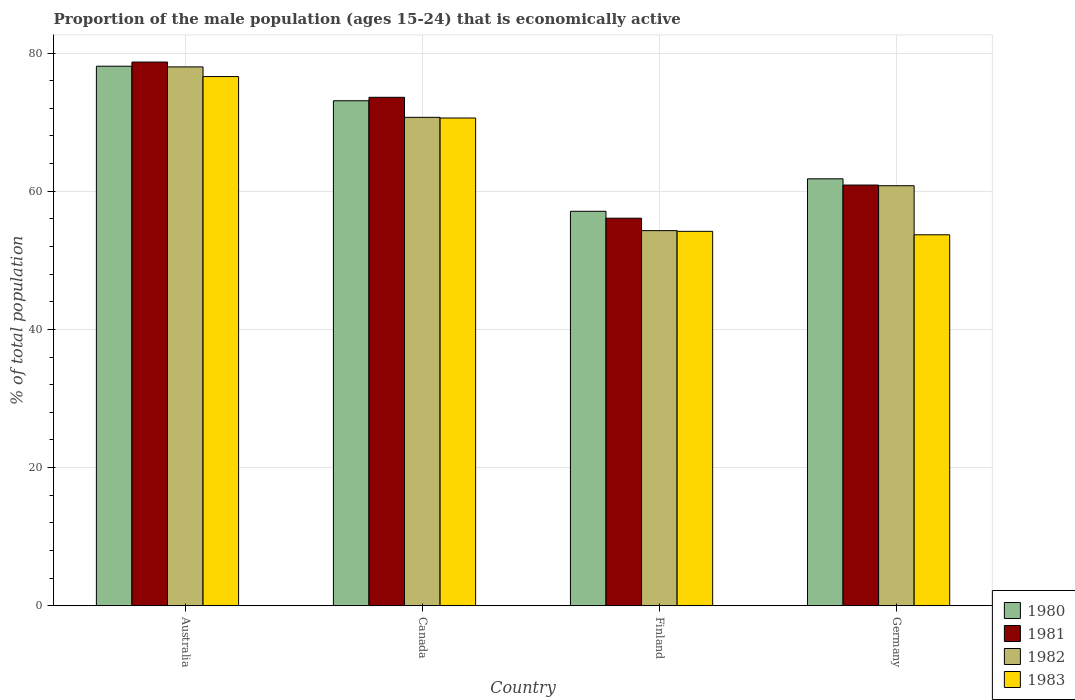How many different coloured bars are there?
Provide a short and direct response. 4. Are the number of bars per tick equal to the number of legend labels?
Provide a short and direct response. Yes. How many bars are there on the 3rd tick from the left?
Make the answer very short. 4. In how many cases, is the number of bars for a given country not equal to the number of legend labels?
Your answer should be very brief. 0. What is the proportion of the male population that is economically active in 1980 in Canada?
Offer a terse response. 73.1. Across all countries, what is the maximum proportion of the male population that is economically active in 1980?
Keep it short and to the point. 78.1. Across all countries, what is the minimum proportion of the male population that is economically active in 1982?
Ensure brevity in your answer.  54.3. In which country was the proportion of the male population that is economically active in 1980 maximum?
Give a very brief answer. Australia. What is the total proportion of the male population that is economically active in 1980 in the graph?
Your response must be concise. 270.1. What is the difference between the proportion of the male population that is economically active in 1982 in Canada and that in Germany?
Offer a terse response. 9.9. What is the difference between the proportion of the male population that is economically active in 1982 in Finland and the proportion of the male population that is economically active in 1981 in Germany?
Offer a very short reply. -6.6. What is the average proportion of the male population that is economically active in 1982 per country?
Keep it short and to the point. 65.95. What is the difference between the proportion of the male population that is economically active of/in 1980 and proportion of the male population that is economically active of/in 1982 in Australia?
Your answer should be compact. 0.1. What is the ratio of the proportion of the male population that is economically active in 1982 in Canada to that in Finland?
Keep it short and to the point. 1.3. Is the proportion of the male population that is economically active in 1982 in Australia less than that in Canada?
Ensure brevity in your answer.  No. What is the difference between the highest and the second highest proportion of the male population that is economically active in 1980?
Offer a very short reply. 11.3. What is the difference between the highest and the lowest proportion of the male population that is economically active in 1980?
Your answer should be compact. 21. In how many countries, is the proportion of the male population that is economically active in 1981 greater than the average proportion of the male population that is economically active in 1981 taken over all countries?
Provide a succinct answer. 2. Is it the case that in every country, the sum of the proportion of the male population that is economically active in 1982 and proportion of the male population that is economically active in 1983 is greater than the sum of proportion of the male population that is economically active in 1980 and proportion of the male population that is economically active in 1981?
Ensure brevity in your answer.  No. How many countries are there in the graph?
Your response must be concise. 4. What is the difference between two consecutive major ticks on the Y-axis?
Your response must be concise. 20. Where does the legend appear in the graph?
Your answer should be compact. Bottom right. How many legend labels are there?
Provide a succinct answer. 4. How are the legend labels stacked?
Offer a terse response. Vertical. What is the title of the graph?
Your response must be concise. Proportion of the male population (ages 15-24) that is economically active. What is the label or title of the X-axis?
Keep it short and to the point. Country. What is the label or title of the Y-axis?
Your answer should be compact. % of total population. What is the % of total population in 1980 in Australia?
Your response must be concise. 78.1. What is the % of total population of 1981 in Australia?
Give a very brief answer. 78.7. What is the % of total population in 1982 in Australia?
Ensure brevity in your answer.  78. What is the % of total population of 1983 in Australia?
Offer a terse response. 76.6. What is the % of total population of 1980 in Canada?
Offer a terse response. 73.1. What is the % of total population in 1981 in Canada?
Keep it short and to the point. 73.6. What is the % of total population of 1982 in Canada?
Your response must be concise. 70.7. What is the % of total population of 1983 in Canada?
Your answer should be compact. 70.6. What is the % of total population of 1980 in Finland?
Your answer should be compact. 57.1. What is the % of total population of 1981 in Finland?
Your answer should be very brief. 56.1. What is the % of total population of 1982 in Finland?
Your response must be concise. 54.3. What is the % of total population of 1983 in Finland?
Provide a short and direct response. 54.2. What is the % of total population of 1980 in Germany?
Give a very brief answer. 61.8. What is the % of total population in 1981 in Germany?
Provide a succinct answer. 60.9. What is the % of total population of 1982 in Germany?
Keep it short and to the point. 60.8. What is the % of total population of 1983 in Germany?
Offer a terse response. 53.7. Across all countries, what is the maximum % of total population of 1980?
Ensure brevity in your answer.  78.1. Across all countries, what is the maximum % of total population in 1981?
Keep it short and to the point. 78.7. Across all countries, what is the maximum % of total population of 1983?
Your answer should be compact. 76.6. Across all countries, what is the minimum % of total population of 1980?
Your response must be concise. 57.1. Across all countries, what is the minimum % of total population in 1981?
Provide a succinct answer. 56.1. Across all countries, what is the minimum % of total population in 1982?
Offer a very short reply. 54.3. Across all countries, what is the minimum % of total population of 1983?
Your response must be concise. 53.7. What is the total % of total population in 1980 in the graph?
Provide a short and direct response. 270.1. What is the total % of total population of 1981 in the graph?
Your answer should be very brief. 269.3. What is the total % of total population in 1982 in the graph?
Ensure brevity in your answer.  263.8. What is the total % of total population of 1983 in the graph?
Make the answer very short. 255.1. What is the difference between the % of total population of 1980 in Australia and that in Canada?
Keep it short and to the point. 5. What is the difference between the % of total population of 1981 in Australia and that in Finland?
Make the answer very short. 22.6. What is the difference between the % of total population of 1982 in Australia and that in Finland?
Provide a short and direct response. 23.7. What is the difference between the % of total population in 1983 in Australia and that in Finland?
Your answer should be very brief. 22.4. What is the difference between the % of total population in 1981 in Australia and that in Germany?
Provide a short and direct response. 17.8. What is the difference between the % of total population in 1982 in Australia and that in Germany?
Offer a very short reply. 17.2. What is the difference between the % of total population of 1983 in Australia and that in Germany?
Keep it short and to the point. 22.9. What is the difference between the % of total population of 1980 in Canada and that in Finland?
Make the answer very short. 16. What is the difference between the % of total population in 1981 in Canada and that in Finland?
Your response must be concise. 17.5. What is the difference between the % of total population in 1982 in Canada and that in Finland?
Your answer should be compact. 16.4. What is the difference between the % of total population in 1981 in Finland and that in Germany?
Your response must be concise. -4.8. What is the difference between the % of total population of 1982 in Finland and that in Germany?
Ensure brevity in your answer.  -6.5. What is the difference between the % of total population of 1980 in Australia and the % of total population of 1982 in Canada?
Provide a short and direct response. 7.4. What is the difference between the % of total population in 1981 in Australia and the % of total population in 1982 in Canada?
Provide a short and direct response. 8. What is the difference between the % of total population of 1982 in Australia and the % of total population of 1983 in Canada?
Make the answer very short. 7.4. What is the difference between the % of total population in 1980 in Australia and the % of total population in 1982 in Finland?
Offer a very short reply. 23.8. What is the difference between the % of total population of 1980 in Australia and the % of total population of 1983 in Finland?
Your answer should be very brief. 23.9. What is the difference between the % of total population of 1981 in Australia and the % of total population of 1982 in Finland?
Keep it short and to the point. 24.4. What is the difference between the % of total population of 1982 in Australia and the % of total population of 1983 in Finland?
Your answer should be compact. 23.8. What is the difference between the % of total population in 1980 in Australia and the % of total population in 1982 in Germany?
Keep it short and to the point. 17.3. What is the difference between the % of total population of 1980 in Australia and the % of total population of 1983 in Germany?
Ensure brevity in your answer.  24.4. What is the difference between the % of total population of 1981 in Australia and the % of total population of 1982 in Germany?
Ensure brevity in your answer.  17.9. What is the difference between the % of total population of 1981 in Australia and the % of total population of 1983 in Germany?
Your response must be concise. 25. What is the difference between the % of total population in 1982 in Australia and the % of total population in 1983 in Germany?
Provide a succinct answer. 24.3. What is the difference between the % of total population in 1981 in Canada and the % of total population in 1982 in Finland?
Your response must be concise. 19.3. What is the difference between the % of total population of 1980 in Canada and the % of total population of 1981 in Germany?
Make the answer very short. 12.2. What is the difference between the % of total population in 1982 in Canada and the % of total population in 1983 in Germany?
Make the answer very short. 17. What is the difference between the % of total population of 1980 in Finland and the % of total population of 1981 in Germany?
Keep it short and to the point. -3.8. What is the difference between the % of total population of 1980 in Finland and the % of total population of 1982 in Germany?
Offer a very short reply. -3.7. What is the difference between the % of total population of 1980 in Finland and the % of total population of 1983 in Germany?
Your answer should be compact. 3.4. What is the difference between the % of total population in 1981 in Finland and the % of total population in 1982 in Germany?
Make the answer very short. -4.7. What is the difference between the % of total population of 1981 in Finland and the % of total population of 1983 in Germany?
Make the answer very short. 2.4. What is the difference between the % of total population of 1982 in Finland and the % of total population of 1983 in Germany?
Your answer should be very brief. 0.6. What is the average % of total population in 1980 per country?
Your answer should be very brief. 67.53. What is the average % of total population of 1981 per country?
Give a very brief answer. 67.33. What is the average % of total population of 1982 per country?
Offer a very short reply. 65.95. What is the average % of total population of 1983 per country?
Offer a very short reply. 63.77. What is the difference between the % of total population of 1980 and % of total population of 1981 in Australia?
Offer a very short reply. -0.6. What is the difference between the % of total population in 1980 and % of total population in 1983 in Australia?
Ensure brevity in your answer.  1.5. What is the difference between the % of total population in 1982 and % of total population in 1983 in Australia?
Your answer should be compact. 1.4. What is the difference between the % of total population in 1980 and % of total population in 1982 in Canada?
Provide a succinct answer. 2.4. What is the difference between the % of total population in 1980 and % of total population in 1983 in Canada?
Your response must be concise. 2.5. What is the difference between the % of total population in 1980 and % of total population in 1981 in Finland?
Your response must be concise. 1. What is the difference between the % of total population of 1981 and % of total population of 1983 in Finland?
Your response must be concise. 1.9. What is the difference between the % of total population of 1982 and % of total population of 1983 in Finland?
Ensure brevity in your answer.  0.1. What is the difference between the % of total population in 1980 and % of total population in 1982 in Germany?
Keep it short and to the point. 1. What is the difference between the % of total population of 1980 and % of total population of 1983 in Germany?
Keep it short and to the point. 8.1. What is the ratio of the % of total population in 1980 in Australia to that in Canada?
Provide a succinct answer. 1.07. What is the ratio of the % of total population in 1981 in Australia to that in Canada?
Provide a short and direct response. 1.07. What is the ratio of the % of total population of 1982 in Australia to that in Canada?
Keep it short and to the point. 1.1. What is the ratio of the % of total population in 1983 in Australia to that in Canada?
Provide a succinct answer. 1.08. What is the ratio of the % of total population in 1980 in Australia to that in Finland?
Ensure brevity in your answer.  1.37. What is the ratio of the % of total population in 1981 in Australia to that in Finland?
Give a very brief answer. 1.4. What is the ratio of the % of total population of 1982 in Australia to that in Finland?
Your answer should be compact. 1.44. What is the ratio of the % of total population of 1983 in Australia to that in Finland?
Your response must be concise. 1.41. What is the ratio of the % of total population in 1980 in Australia to that in Germany?
Your answer should be very brief. 1.26. What is the ratio of the % of total population in 1981 in Australia to that in Germany?
Give a very brief answer. 1.29. What is the ratio of the % of total population in 1982 in Australia to that in Germany?
Provide a succinct answer. 1.28. What is the ratio of the % of total population in 1983 in Australia to that in Germany?
Your answer should be very brief. 1.43. What is the ratio of the % of total population of 1980 in Canada to that in Finland?
Ensure brevity in your answer.  1.28. What is the ratio of the % of total population in 1981 in Canada to that in Finland?
Your answer should be compact. 1.31. What is the ratio of the % of total population in 1982 in Canada to that in Finland?
Offer a very short reply. 1.3. What is the ratio of the % of total population of 1983 in Canada to that in Finland?
Keep it short and to the point. 1.3. What is the ratio of the % of total population of 1980 in Canada to that in Germany?
Your response must be concise. 1.18. What is the ratio of the % of total population of 1981 in Canada to that in Germany?
Make the answer very short. 1.21. What is the ratio of the % of total population in 1982 in Canada to that in Germany?
Your response must be concise. 1.16. What is the ratio of the % of total population of 1983 in Canada to that in Germany?
Ensure brevity in your answer.  1.31. What is the ratio of the % of total population in 1980 in Finland to that in Germany?
Your answer should be compact. 0.92. What is the ratio of the % of total population of 1981 in Finland to that in Germany?
Provide a short and direct response. 0.92. What is the ratio of the % of total population of 1982 in Finland to that in Germany?
Your answer should be very brief. 0.89. What is the ratio of the % of total population in 1983 in Finland to that in Germany?
Your answer should be compact. 1.01. What is the difference between the highest and the lowest % of total population of 1980?
Ensure brevity in your answer.  21. What is the difference between the highest and the lowest % of total population of 1981?
Your response must be concise. 22.6. What is the difference between the highest and the lowest % of total population of 1982?
Ensure brevity in your answer.  23.7. What is the difference between the highest and the lowest % of total population of 1983?
Your answer should be very brief. 22.9. 